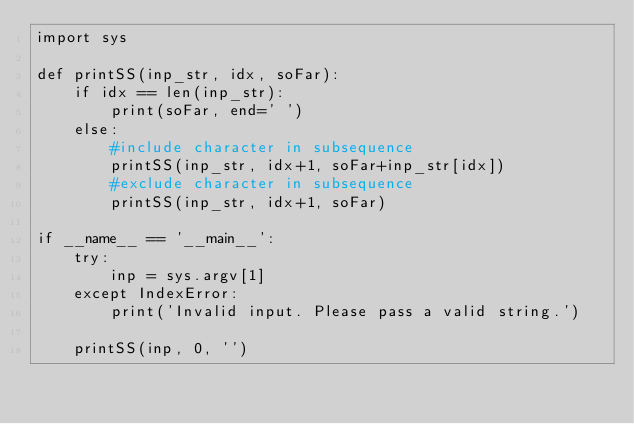Convert code to text. <code><loc_0><loc_0><loc_500><loc_500><_Python_>import sys

def printSS(inp_str, idx, soFar):
    if idx == len(inp_str):
        print(soFar, end=' ')
    else:
        #include character in subsequence
        printSS(inp_str, idx+1, soFar+inp_str[idx])
        #exclude character in subsequence
        printSS(inp_str, idx+1, soFar)

if __name__ == '__main__':
    try:
        inp = sys.argv[1]
    except IndexError:
        print('Invalid input. Please pass a valid string.')

    printSS(inp, 0, '')</code> 